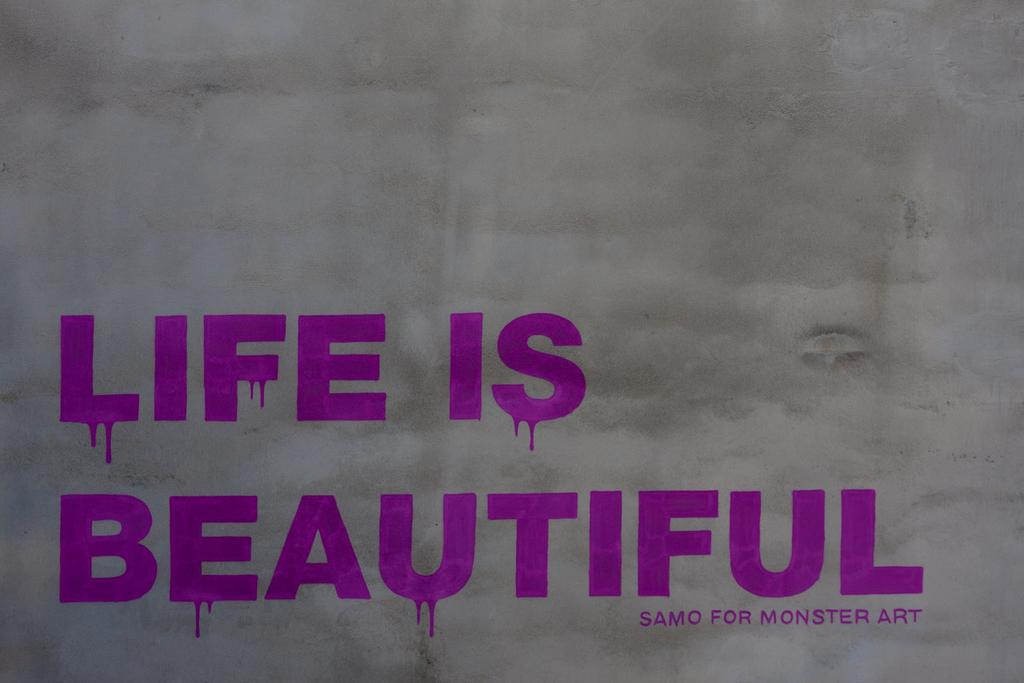What is present on the wall in the image? There is text on the wall in the image. Can you describe the text on the wall? Unfortunately, the specific content of the text cannot be determined from the provided facts. What is the primary purpose of the wall in the image? The primary purpose of the wall in the image is to support the text. What type of business is being advertised by the ghost in the image? There is no ghost present in the image, and therefore no business is being advertised by a ghost. 